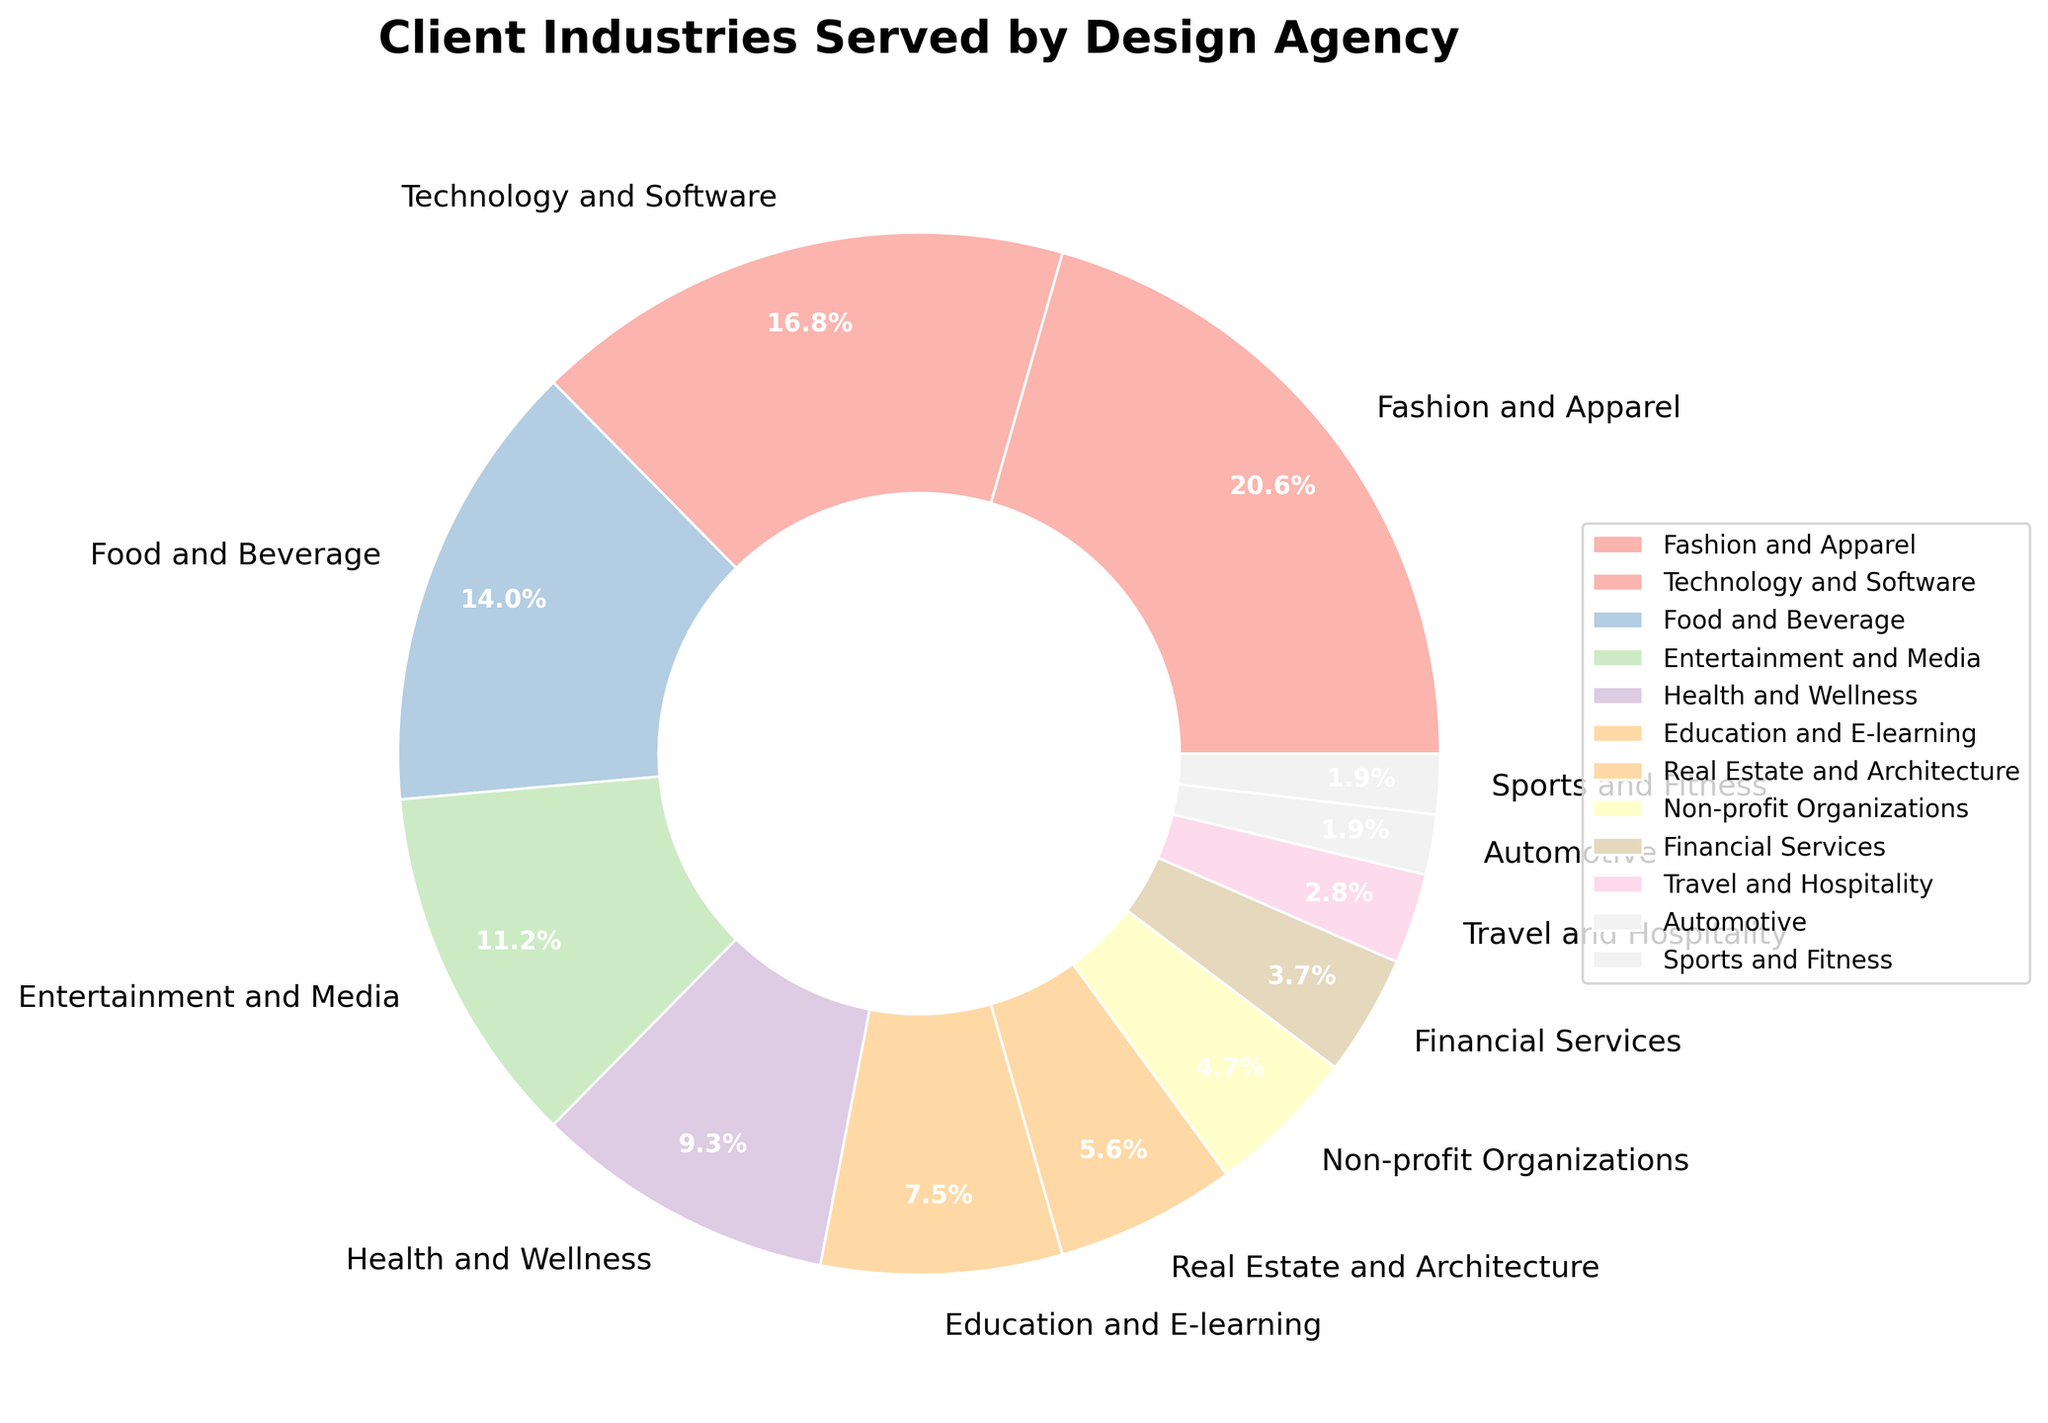What is the most served industry by the design agency? The pie chart indicates that the largest segment belongs to Fashion and Apparel, which represents 22% of the total percentage.
Answer: Fashion and Apparel Which industry has a higher percentage, Food and Beverage or Entertainment and Media? By examining the pie chart, Food and Beverage holds 15% while Entertainment and Media has 12%. Thus, Food and Beverage has a higher percentage.
Answer: Food and Beverage How much larger is the percentage for Technology and Software compared to Health and Wellness? According to the chart, Technology and Software accounts for 18% and Health and Wellness accounts for 10%. The difference is 18% - 10% = 8%.
Answer: 8% What is the sum of percentages for the Fashion and Apparel, Technology and Software, and Food and Beverage industries? The individual percentages for these industries are 22% for Fashion and Apparel, 18% for Technology and Software, and 15% for Food and Beverage. Adding these up gives 22% + 18% + 15% = 55%.
Answer: 55% Which industries combined have a percentage equal to or greater than that of Education and E-learning? Education and E-learning represents 8%. Non-profit Organizations (5%) plus Financial Services (4%) is 9%, which is greater than 8%. Hence, Non-profit Organizations and Financial Services combined can be compared.
Answer: Non-profit Organizations and Financial Services Is the percentage for Real Estate and Architecture smaller than that for Health and Wellness? If so, by how much? Real Estate and Architecture has 6%, while Health and Wellness has 10%. The difference is 10% - 6% = 4%. Therefore, it is smaller by 4%.
Answer: Yes, by 4% Identify the industries that have percentages of 3% or lower. The industries displayed in the pie chart with percentages of 3% or lower are Travel and Hospitality (3%), Automotive (2%), and Sports and Fitness (2%).
Answer: Travel and Hospitality, Automotive, and Sports and Fitness What is the combined percentage of the least represented industries, given they share an equal 2% each? The least represented industries are Automotive and Sports and Fitness, each having 2%. Their combined percentage is 2% + 2% = 4%.
Answer: 4% Among Non-profit Organizations, Financial Services, and Travel and Hospitality, which has the smallest percentage? The pie chart shows that Non-profit Organizations have 5%, Financial Services have 4%, and Travel and Hospitality have 3%. Therefore, Travel and Hospitality has the smallest percentage.
Answer: Travel and Hospitality What is the average percentage of the top three industries served by the design agency? The top three industries by percentage are Fashion and Apparel (22%), Technology and Software (18%), and Food and Beverage (15%). The average percentage is calculated by (22% + 18% + 15%) / 3 = 55% / 3 ≈ 18.33%.
Answer: 18.33% 